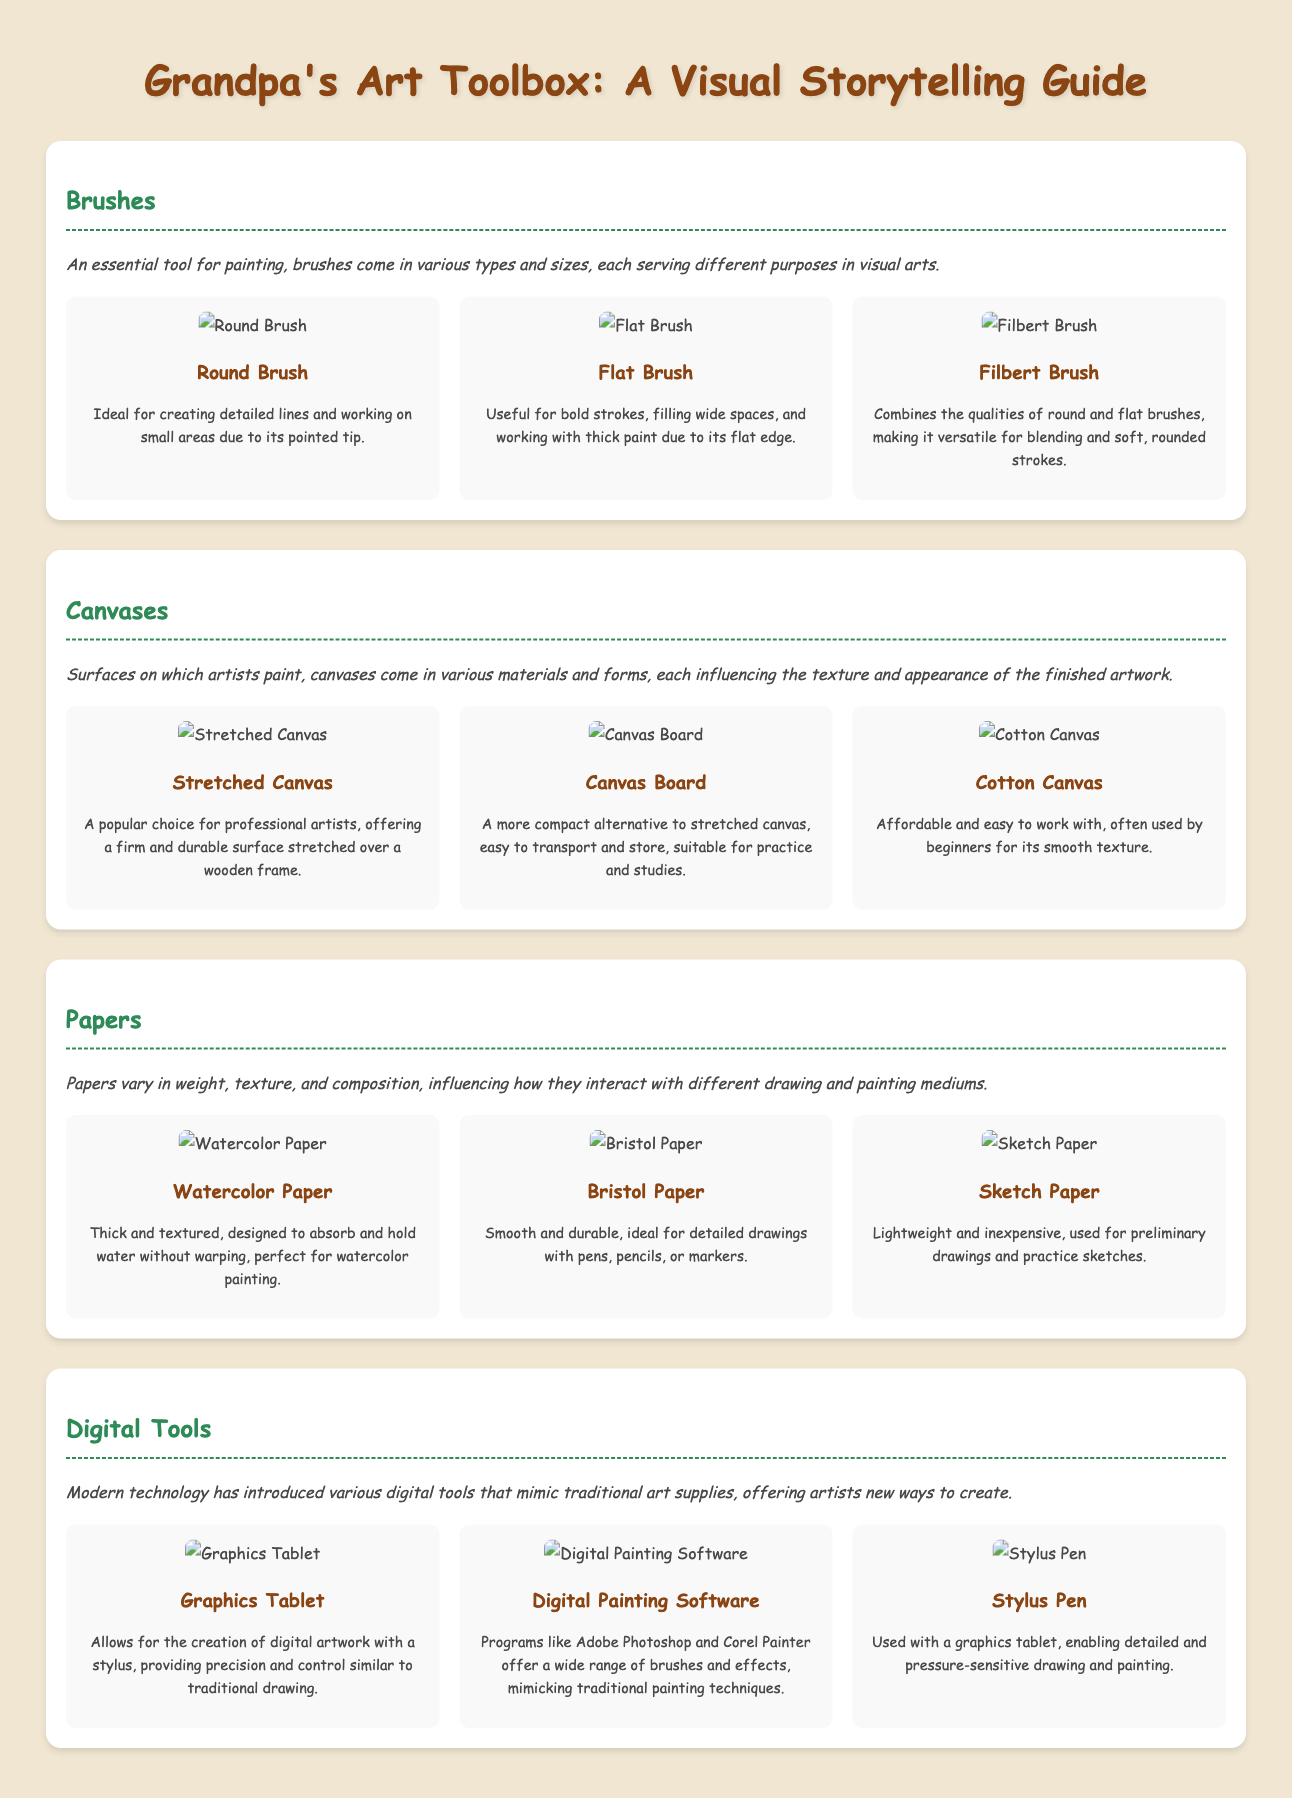What is a round brush ideal for? The round brush is ideal for creating detailed lines and working on small areas due to its pointed tip.
Answer: Detailed lines What type of canvas is popular among professional artists? The popular choice for professional artists is stretched canvas, which offers a firm and durable surface stretched over a wooden frame.
Answer: Stretched Canvas What is watercolor paper designed to do? Watercolor paper is designed to absorb and hold water without warping, perfect for watercolor painting.
Answer: Absorb water Which paper is ideal for detailed drawings with pens, pencils, or markers? Bristol paper is ideal for detailed drawings with pens, pencils, or markers due to its smooth and durable texture.
Answer: Bristol Paper What digital tool allows for the creation of digital artwork with a stylus? A graphics tablet allows for the creation of digital artwork with a stylus, providing precision and control similar to traditional drawing.
Answer: Graphics Tablet What does a stylus pen enable when used with a graphics tablet? A stylus pen enables detailed and pressure-sensitive drawing and painting when used with a graphics tablet.
Answer: Detailed drawing Which brush combines the qualities of round and flat brushes? The filbert brush combines the qualities of round and flat brushes, making it versatile for blending and soft, rounded strokes.
Answer: Filbert Brush What type of canvas is described as more compact and easy to transport? Canvas board is described as a more compact alternative to stretched canvas, easy to transport and store.
Answer: Canvas Board 